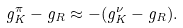<formula> <loc_0><loc_0><loc_500><loc_500>g ^ { \pi } _ { K } - g _ { R } \approx - ( g ^ { \nu } _ { K } - g _ { R } ) .</formula> 